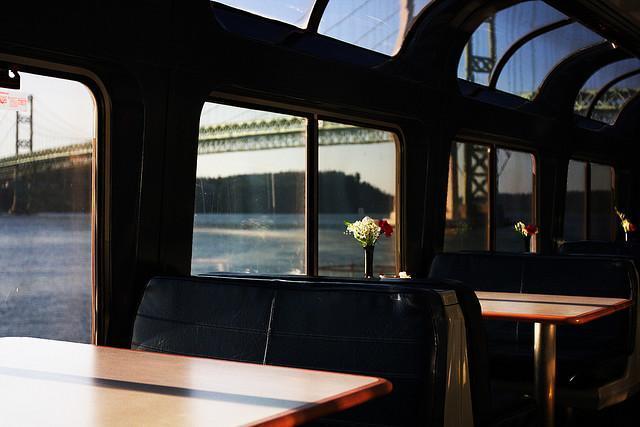How many planes?
Give a very brief answer. 0. How many dining tables are there?
Give a very brief answer. 2. How many people in this photo?
Give a very brief answer. 0. 